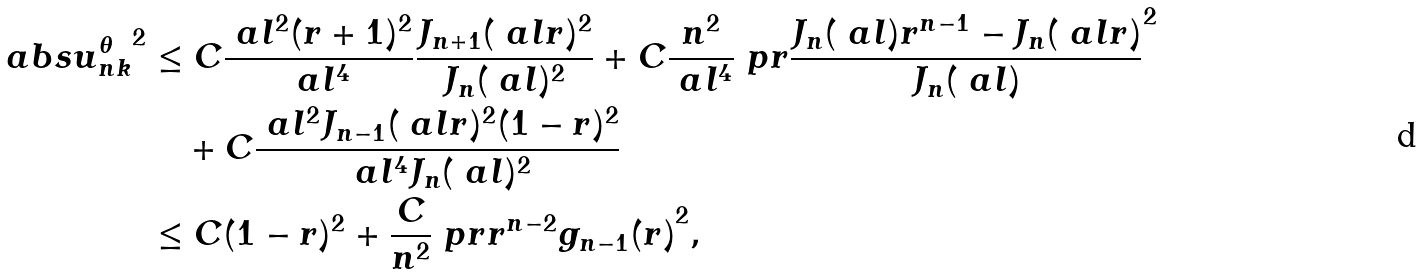<formula> <loc_0><loc_0><loc_500><loc_500>a b s { u _ { n k } ^ { \theta } } ^ { 2 } & \leq C \frac { \ a l ^ { 2 } ( r + 1 ) ^ { 2 } } { \ a l ^ { 4 } } \frac { J _ { n + 1 } ( \ a l r ) ^ { 2 } } { J _ { n } ( \ a l ) ^ { 2 } } + C \frac { n ^ { 2 } } { \ a l ^ { 4 } } \ p r { \frac { J _ { n } ( \ a l ) r ^ { n - 1 } - J _ { n } ( \ a l r ) } { J _ { n } ( \ a l ) } } ^ { 2 } \\ & \quad + C \frac { \ a l ^ { 2 } J _ { n - 1 } ( \ a l r ) ^ { 2 } ( 1 - r ) ^ { 2 } } { \ a l ^ { 4 } J _ { n } ( \ a l ) ^ { 2 } } \\ & \leq C ( 1 - r ) ^ { 2 } + \frac { C } { n ^ { 2 } } \ p r { r ^ { n - 2 } g _ { n - 1 } ( r ) } ^ { 2 } ,</formula> 